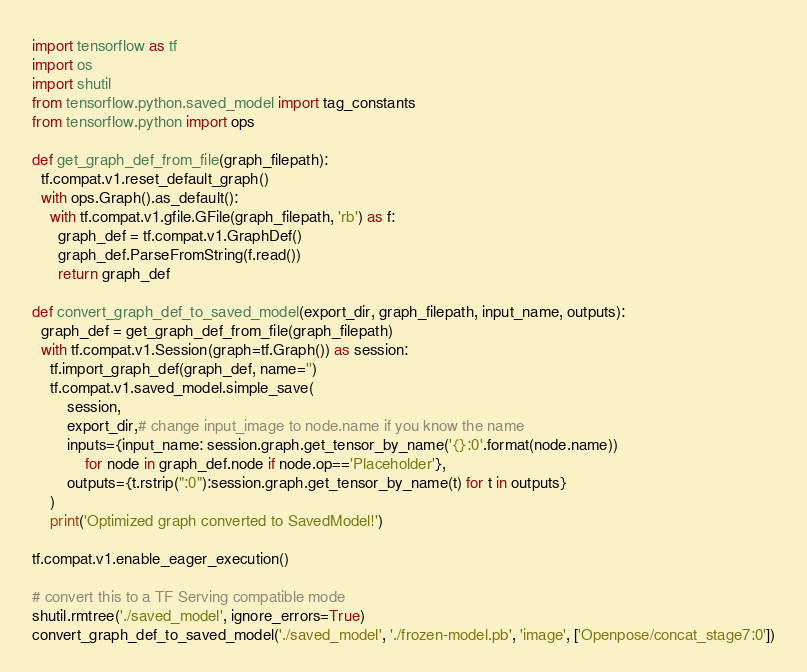<code> <loc_0><loc_0><loc_500><loc_500><_Python_>import tensorflow as tf
import os
import shutil
from tensorflow.python.saved_model import tag_constants
from tensorflow.python import ops

def get_graph_def_from_file(graph_filepath):
  tf.compat.v1.reset_default_graph()
  with ops.Graph().as_default():
    with tf.compat.v1.gfile.GFile(graph_filepath, 'rb') as f:
      graph_def = tf.compat.v1.GraphDef()
      graph_def.ParseFromString(f.read())
      return graph_def

def convert_graph_def_to_saved_model(export_dir, graph_filepath, input_name, outputs):
  graph_def = get_graph_def_from_file(graph_filepath)
  with tf.compat.v1.Session(graph=tf.Graph()) as session:
    tf.import_graph_def(graph_def, name='')
    tf.compat.v1.saved_model.simple_save(
        session,
        export_dir,# change input_image to node.name if you know the name
        inputs={input_name: session.graph.get_tensor_by_name('{}:0'.format(node.name))
            for node in graph_def.node if node.op=='Placeholder'},
        outputs={t.rstrip(":0"):session.graph.get_tensor_by_name(t) for t in outputs}
    )
    print('Optimized graph converted to SavedModel!')

tf.compat.v1.enable_eager_execution()

# convert this to a TF Serving compatible mode
shutil.rmtree('./saved_model', ignore_errors=True)
convert_graph_def_to_saved_model('./saved_model', './frozen-model.pb', 'image', ['Openpose/concat_stage7:0'])
</code> 